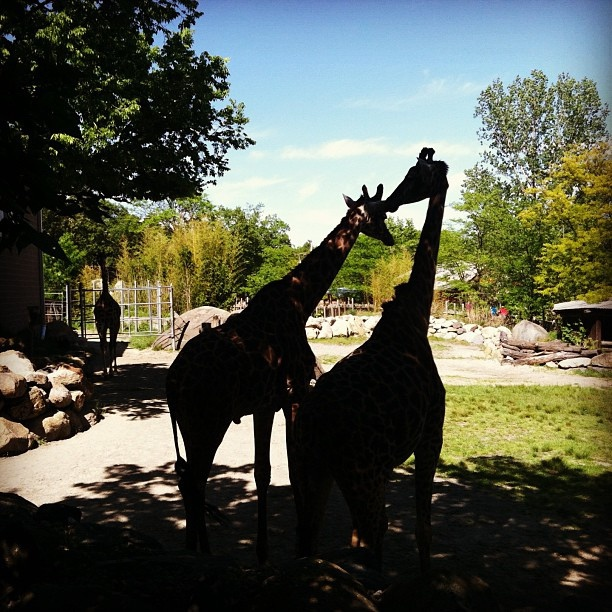Describe the objects in this image and their specific colors. I can see giraffe in black, ivory, gray, and olive tones, giraffe in black, ivory, maroon, and gray tones, and giraffe in black, ivory, darkgreen, and gray tones in this image. 